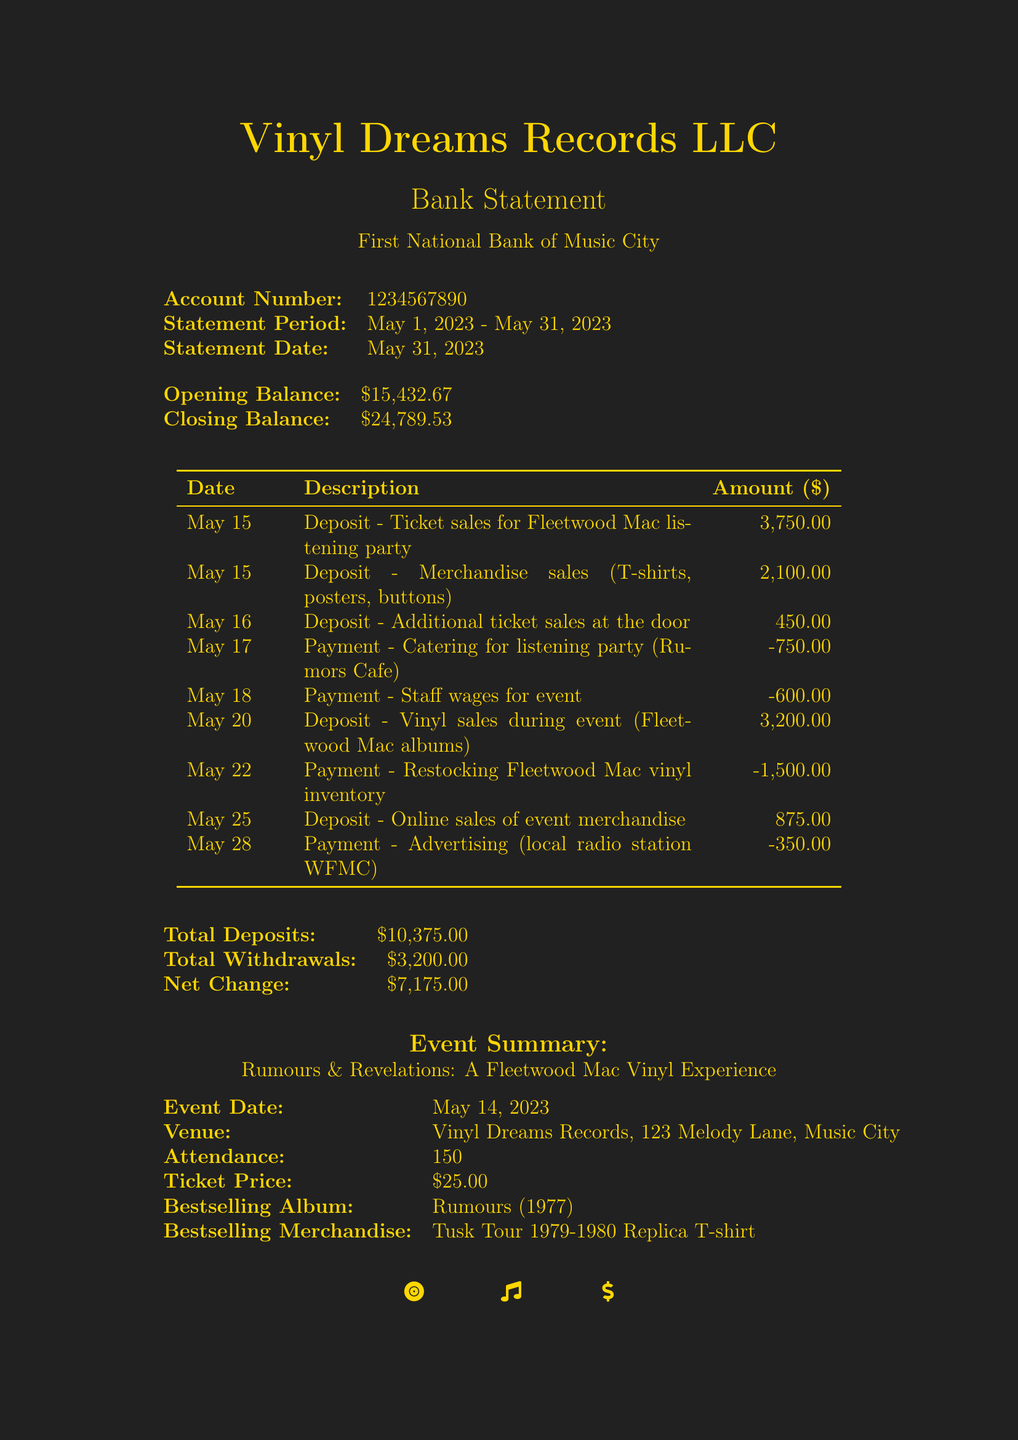What is the account holder's name? The document specifies the account holder as "Vinyl Dreams Records LLC."
Answer: Vinyl Dreams Records LLC What is the statement date? The document indicates the statement date as "May 31, 2023."
Answer: May 31, 2023 What was the total deposits amount? The document summarizes the total deposits and shows it as "10,375.00."
Answer: 10,375.00 How much was spent on advertising? The payment for advertising is clearly listed as "350.00."
Answer: 350.00 What is the attendance for the event? The document notes the attendance for the event as "150."
Answer: 150 What is the net change for the month? The document calculates the net change as "7,175.00."
Answer: 7,175.00 What percentage of total deposits came from ticket sales? The total from ticket sales is 3,750.00 + 450.00 = 4,200.00. The total deposits are 10,375.00. The ratio is (4,200.00 / 10,375.00) * 100 = 40.44%.
Answer: 40.44% What item was the bestselling merchandise? The document states that the bestselling merchandise item is "Tusk Tour 1979-1980 Replica T-shirt."
Answer: Tusk Tour 1979-1980 Replica T-shirt What is the closing balance of the account? The closing balance is detailed in the document as "24,789.53."
Answer: 24,789.53 